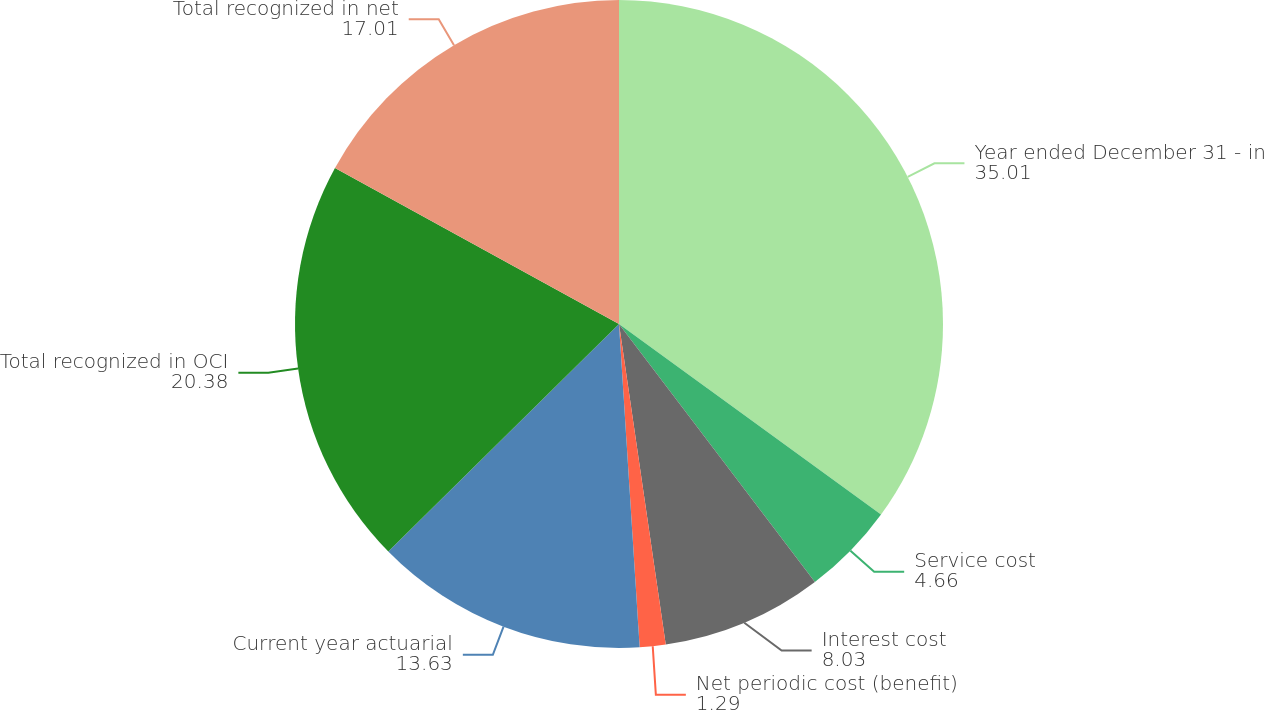Convert chart to OTSL. <chart><loc_0><loc_0><loc_500><loc_500><pie_chart><fcel>Year ended December 31 - in<fcel>Service cost<fcel>Interest cost<fcel>Net periodic cost (benefit)<fcel>Current year actuarial<fcel>Total recognized in OCI<fcel>Total recognized in net<nl><fcel>35.01%<fcel>4.66%<fcel>8.03%<fcel>1.29%<fcel>13.63%<fcel>20.38%<fcel>17.01%<nl></chart> 